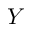Convert formula to latex. <formula><loc_0><loc_0><loc_500><loc_500>Y</formula> 